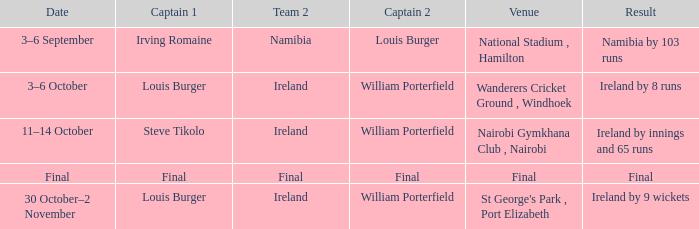Which captain 2 has a score of ireland by 8 runs? William Porterfield. 